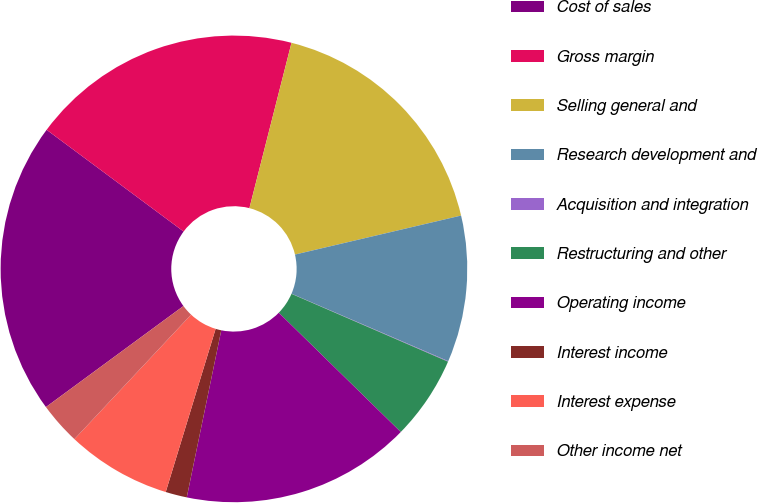Convert chart. <chart><loc_0><loc_0><loc_500><loc_500><pie_chart><fcel>Cost of sales<fcel>Gross margin<fcel>Selling general and<fcel>Research development and<fcel>Acquisition and integration<fcel>Restructuring and other<fcel>Operating income<fcel>Interest income<fcel>Interest expense<fcel>Other income net<nl><fcel>20.25%<fcel>18.8%<fcel>17.36%<fcel>10.14%<fcel>0.04%<fcel>5.81%<fcel>15.92%<fcel>1.48%<fcel>7.26%<fcel>2.93%<nl></chart> 